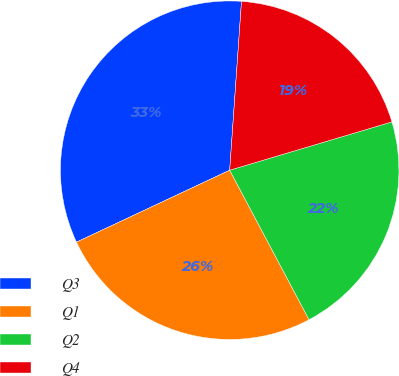Convert chart. <chart><loc_0><loc_0><loc_500><loc_500><pie_chart><fcel>Q3<fcel>Q1<fcel>Q2<fcel>Q4<nl><fcel>33.1%<fcel>25.78%<fcel>21.84%<fcel>19.28%<nl></chart> 